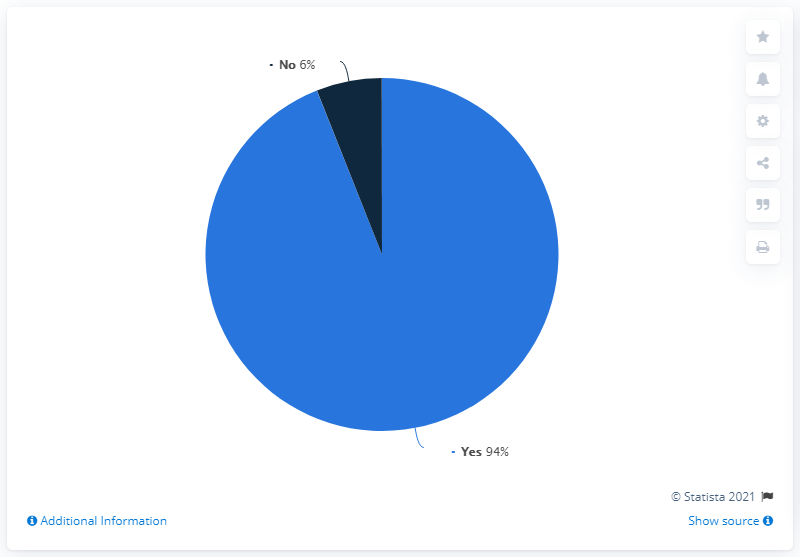Outline some significant characteristics in this image. The difference between "yes" and "no" is 88. Yes, the chart is dominated by the presence of the word 'dogs'. 